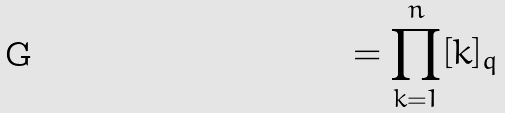Convert formula to latex. <formula><loc_0><loc_0><loc_500><loc_500>= \prod _ { k = 1 } ^ { n } [ k ] _ { q }</formula> 